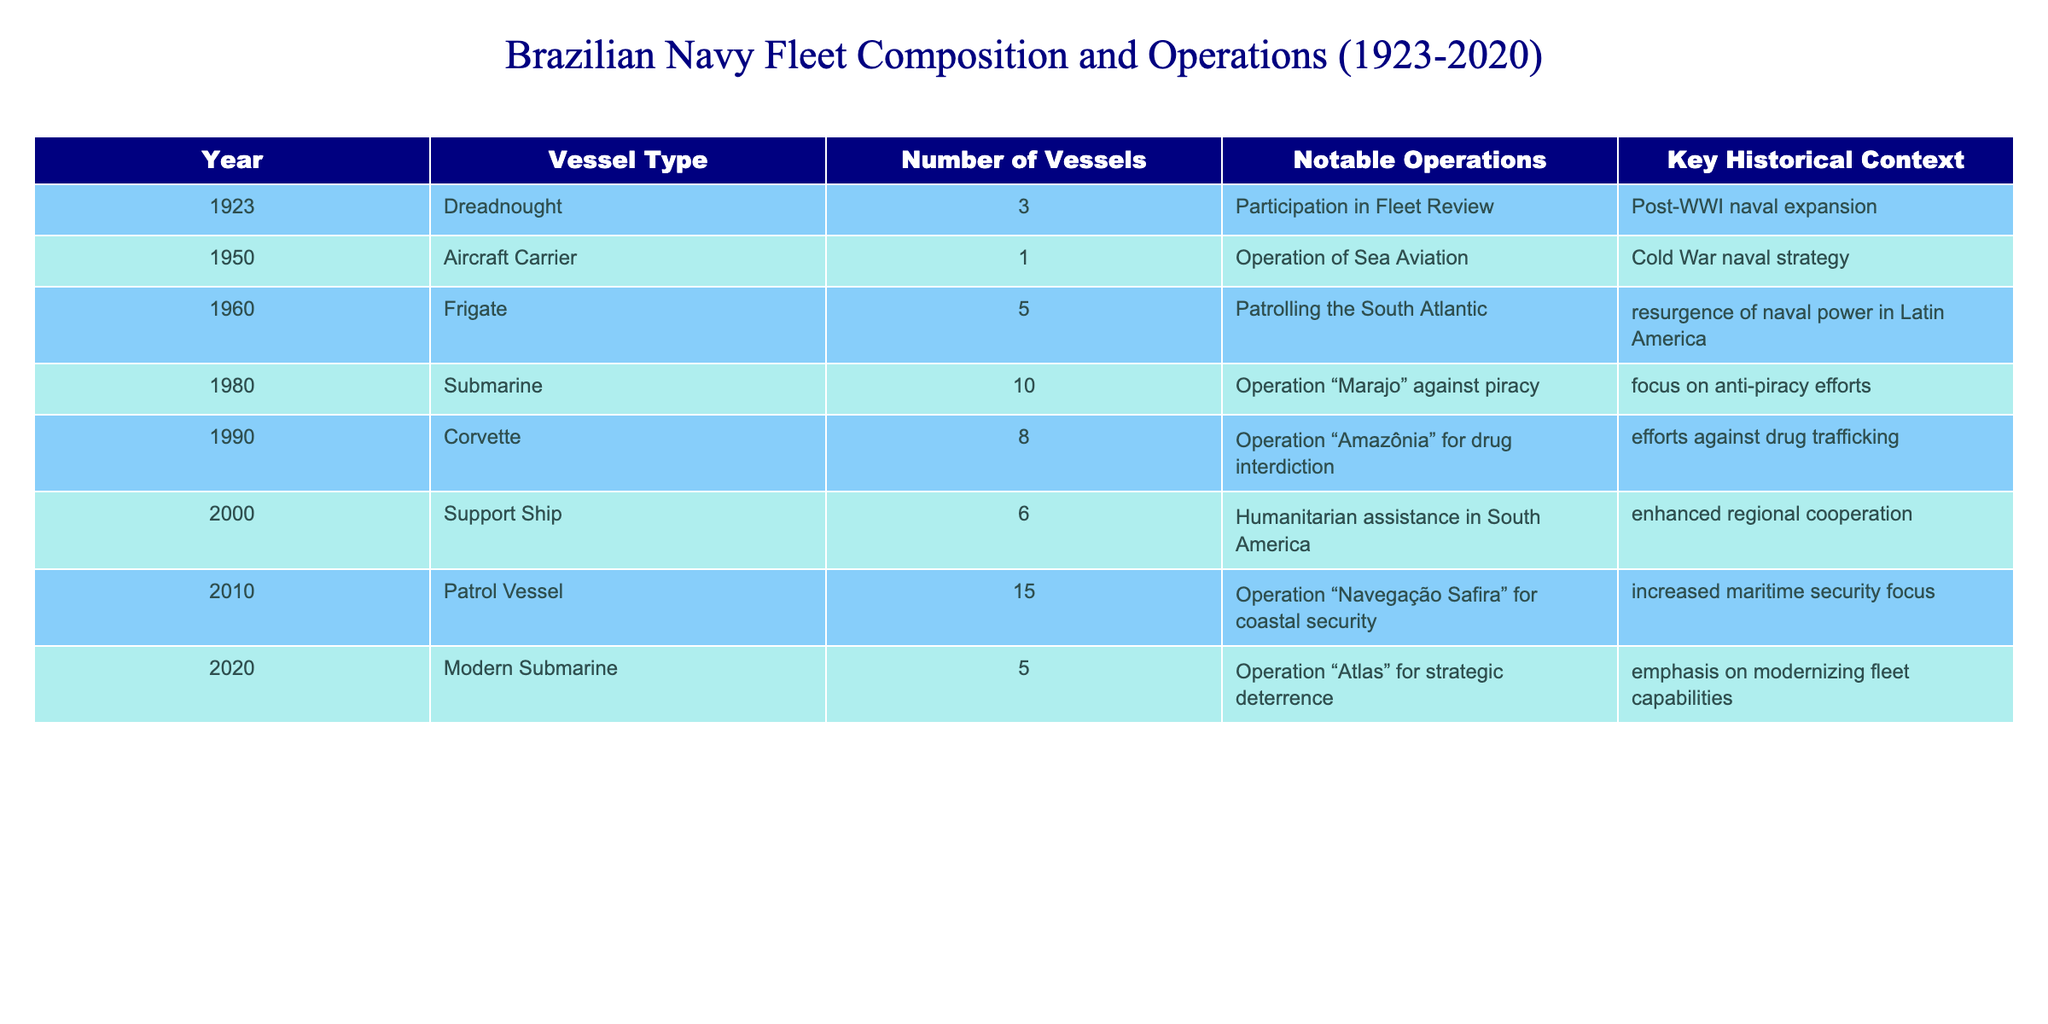What type of vessel was predominant in 1980? In the year 1980, the table shows that submarines were the only type of vessel listed, with a total of 10 submarines. Therefore, the predominant vessel type in that year was submarines.
Answer: Submarine How many corvettes were in the Brazilian Navy in 1990? According to the table, in 1990, the number of corvettes was recorded as 8.
Answer: 8 What notable operation did the Brazilian Navy conduct with frigates in 1960? The table states that in 1960, the Brazilian Navy conducted patrolling operations in the South Atlantic with a fleet of 5 frigates.
Answer: Patrolling the South Atlantic Was there an aircraft carrier in the Brazilian Navy fleet during the Cold War? The table confirms that there was indeed an aircraft carrier present in 1950, coinciding with the Cold War period, where it was involved in sea aviation operations.
Answer: Yes What was the total number of vessels in the Brazilian Navy by 2010? To find this, we need to sum the number of vessels of the listed types in 2010. The table indicates there were 15 patrol vessels in that year. Therefore, the total number of vessels in 2010 is 15.
Answer: 15 What is the difference in the number of submarines between 1980 and 2020? According to the table, there were 10 submarines in 1980 and 5 modern submarines in 2020. The difference is calculated as 10 - 5 = 5.
Answer: 5 What was the key historical context for the vessel types listed in 2000? In 2000, the table indicates that support ships were utilized for humanitarian assistance in South America, which reflects a focus on enhanced regional cooperation.
Answer: Enhanced regional cooperation Which vessel types were involved in anti-piracy efforts in the 1980s? The table specifically mentions that submarines were involved in Operation “Marajo” against piracy in 1980, indicating that submarines were the vessel type associated with anti-piracy efforts during that time.
Answer: Submarines What notable operation involved the Brazilian Navy’s operation of an aircraft carrier? In 1950, the table states the notable operation was the operation of sea aviation with the aircraft carrier during the Cold War naval strategy.
Answer: Operation of Sea Aviation 